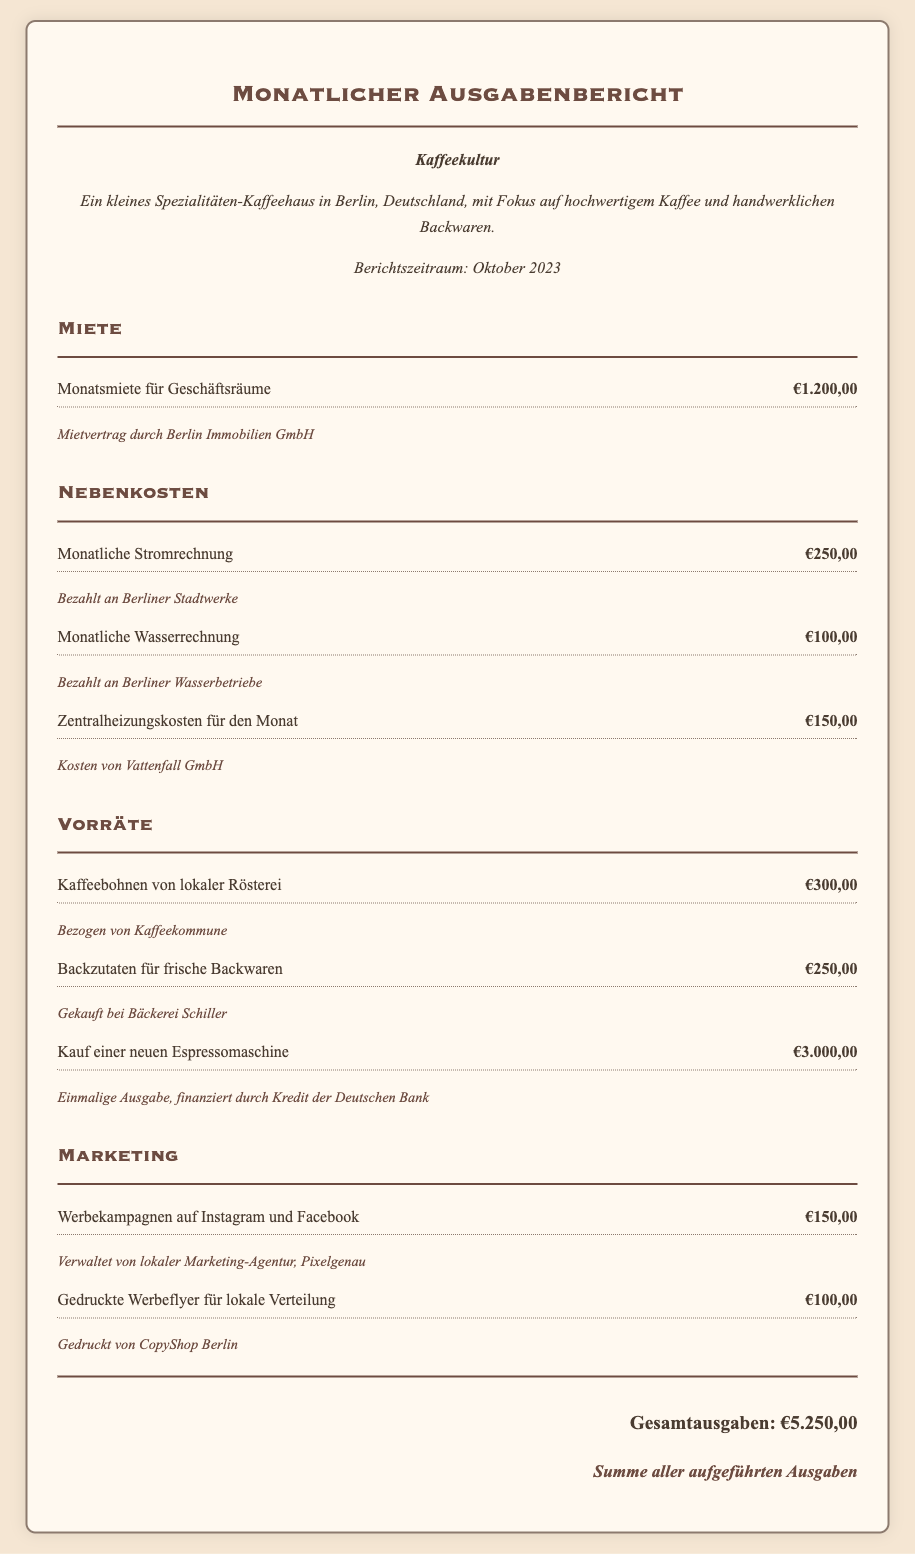Was sind die Gesamtausgaben? Die Gesamtausgaben sind die Summe aller aufgeführten Ausgaben im Bericht.
Answer: €5.250,00 Wie hoch ist die Monatsmiete für Geschäftsräume? Die Monatsmiete für die Geschäftsräume ist eine spezifische Ausgabe im Abschnitt Miete des Berichts.
Answer: €1.200,00 Was waren die Kosten für die Kaffeebohnen? Die Kaffeebohnen sind Teil der Vorräte und haben einen bestimmten Betrag, der im Bericht erwähnt wird.
Answer: €300,00 Wem wurde die monatliche Wasserrechnung bezahlt? Der Bericht erwähnt den Anbieter für die Wasserrechnung in den Nebenkosten.
Answer: Berliner Wasserbetriebe Wie viel wurde für die gedruckten Werbeflyer ausgegeben? Die Ausgabe für die gedruckten Werbeflyer wird im Abschnitt Marketing des Berichts aufgeführt.
Answer: €100,00 Was war der Preis für die neue Espressomaschine? Der Preis befindet sich im Abschnitt Vorräte und ist eine Einzelver-, die dort aufgeführt ist.
Answer: €3.000,00 Wie viel wurde für monatliche Nebenkosten insgesamt ausgegeben? Diese Antwort erfordert die Addition aller spezifischen Nebenkosten im Bericht.
Answer: €500,00 Wer hat die Werbekampagnen verwaltet? Der Bericht nennt die Agentur, die für die Marketingmaßnahmen verantwortlich war.
Answer: Pixelgenau 